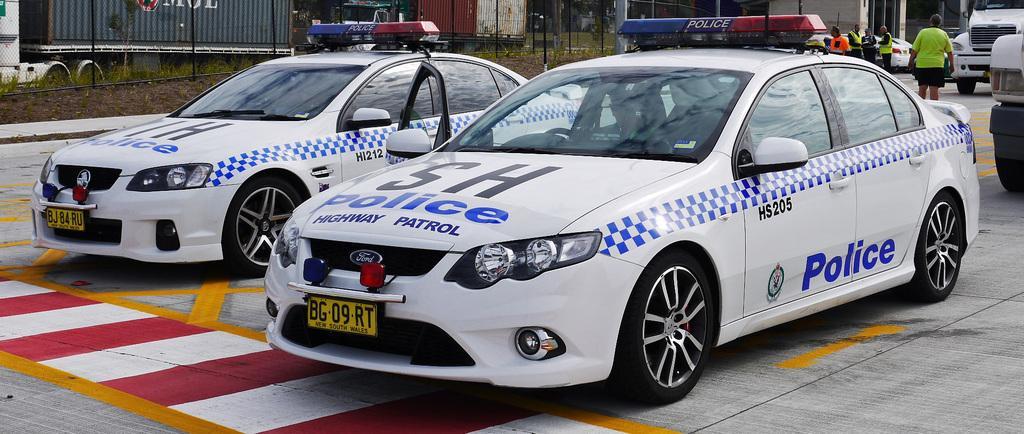Can you describe this image briefly? In this image I can see cars and other vehicles on the road. Seems two cars in the center of the image are police cars I can see some text written on them. I can see some people standing behind the car's, some sheds, pole and buildings. 